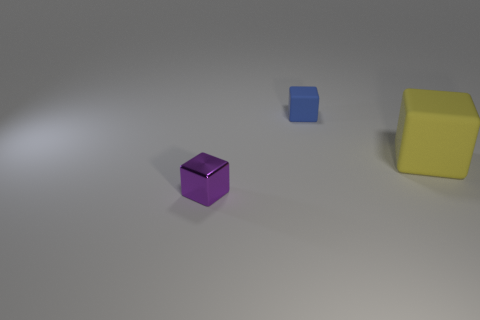Add 1 tiny rubber things. How many objects exist? 4 Subtract all small blocks. How many blocks are left? 1 Subtract all gray blocks. Subtract all gray cylinders. How many blocks are left? 3 Subtract all large green blocks. Subtract all big objects. How many objects are left? 2 Add 2 tiny purple metal cubes. How many tiny purple metal cubes are left? 3 Add 1 large brown rubber blocks. How many large brown rubber blocks exist? 1 Subtract 0 blue spheres. How many objects are left? 3 Subtract 2 cubes. How many cubes are left? 1 